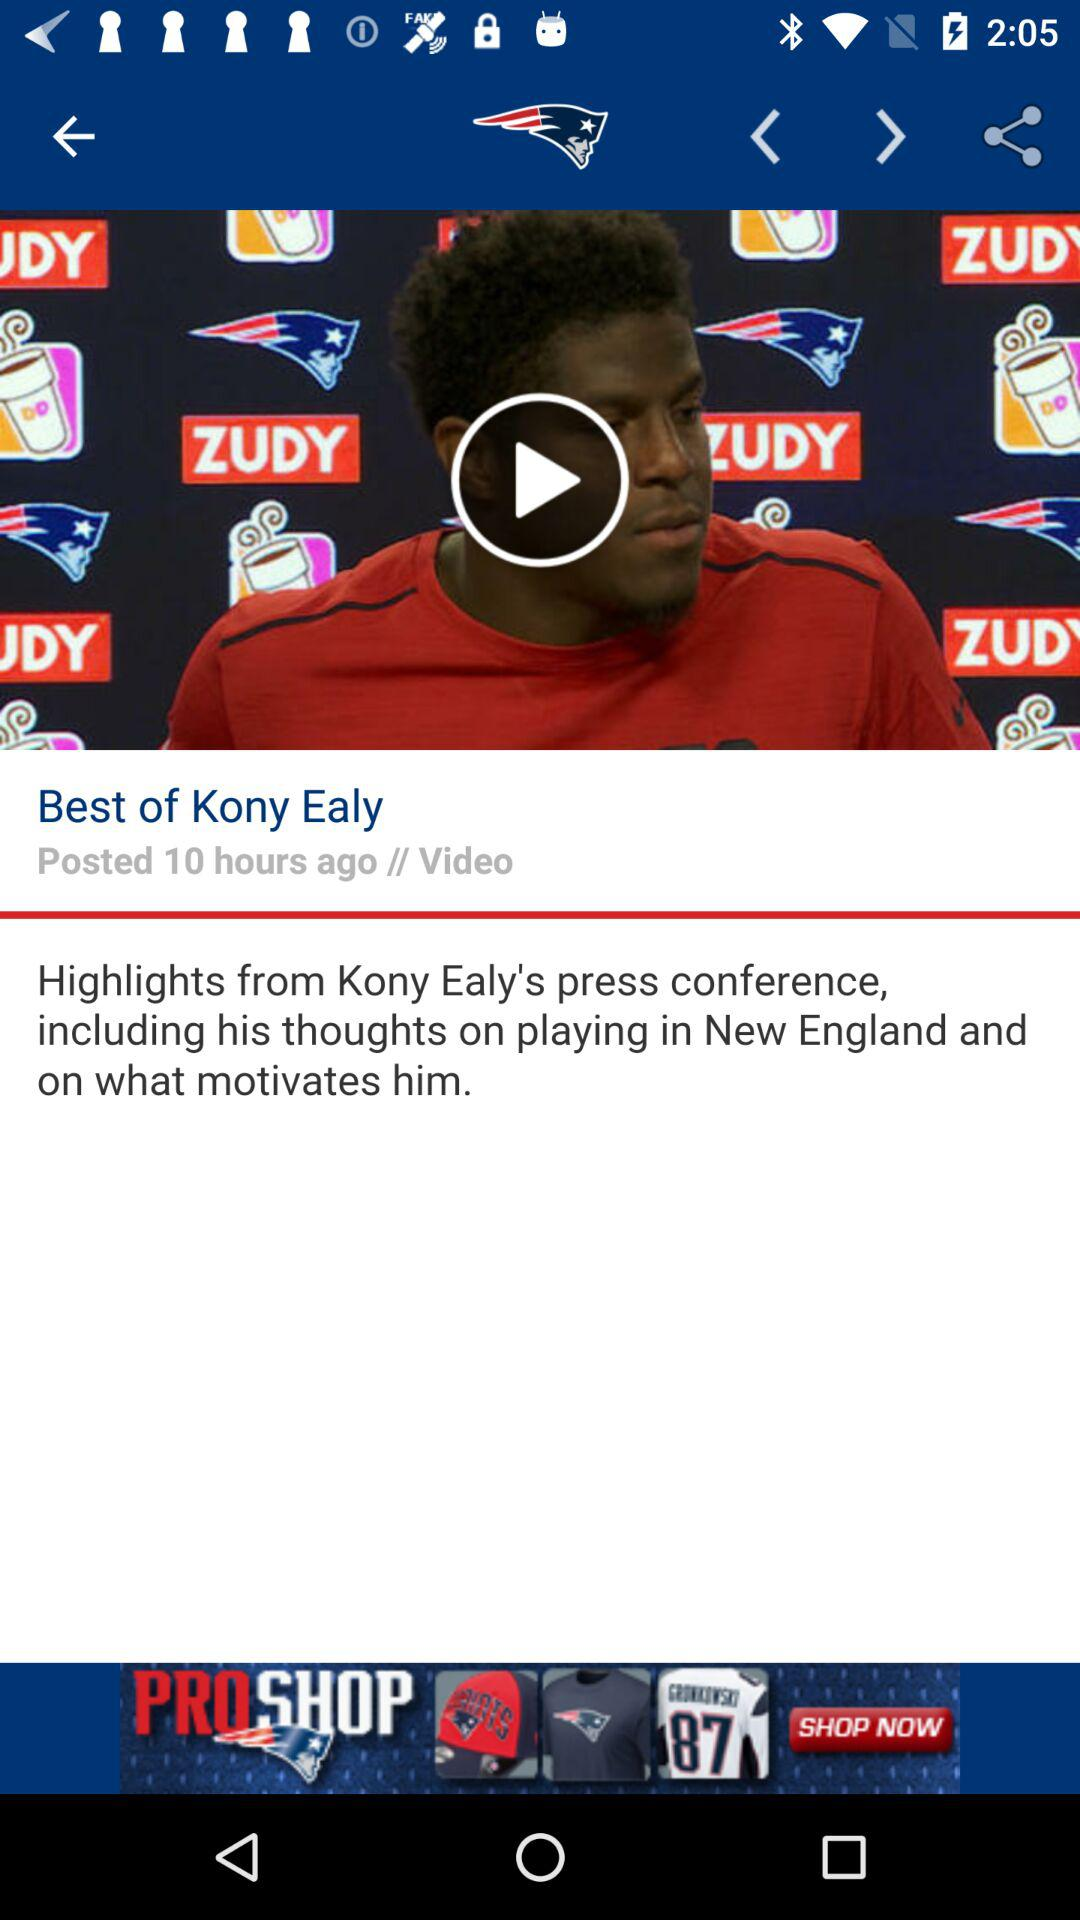What time was the video posted? The video was posted 10 hours ago. 